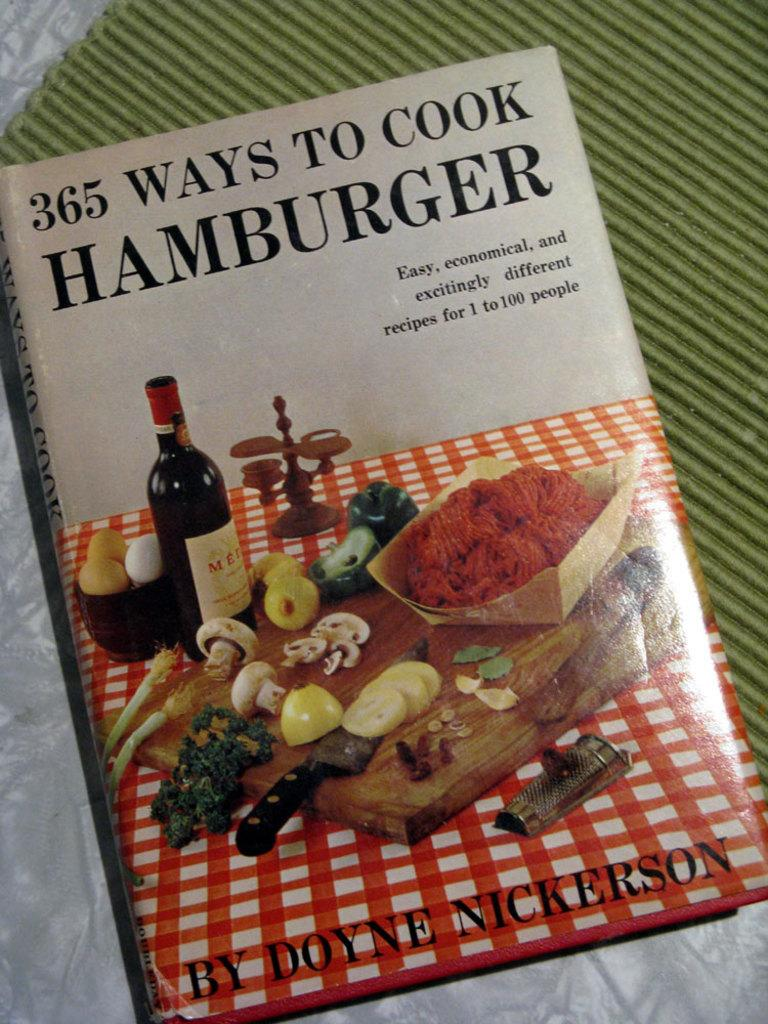<image>
Provide a brief description of the given image. A book on a table says 365 Ways To Cook Hamburger. 